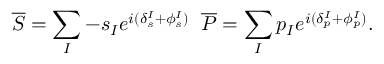Convert formula to latex. <formula><loc_0><loc_0><loc_500><loc_500>\overline { S } = \sum _ { I } - s _ { I } e ^ { i ( \delta _ { s } ^ { I } + \phi _ { s } ^ { I } ) } \, \overline { P } = \sum _ { I } p _ { I } e ^ { i ( \delta _ { p } ^ { I } + \phi _ { p } ^ { I } ) } .</formula> 